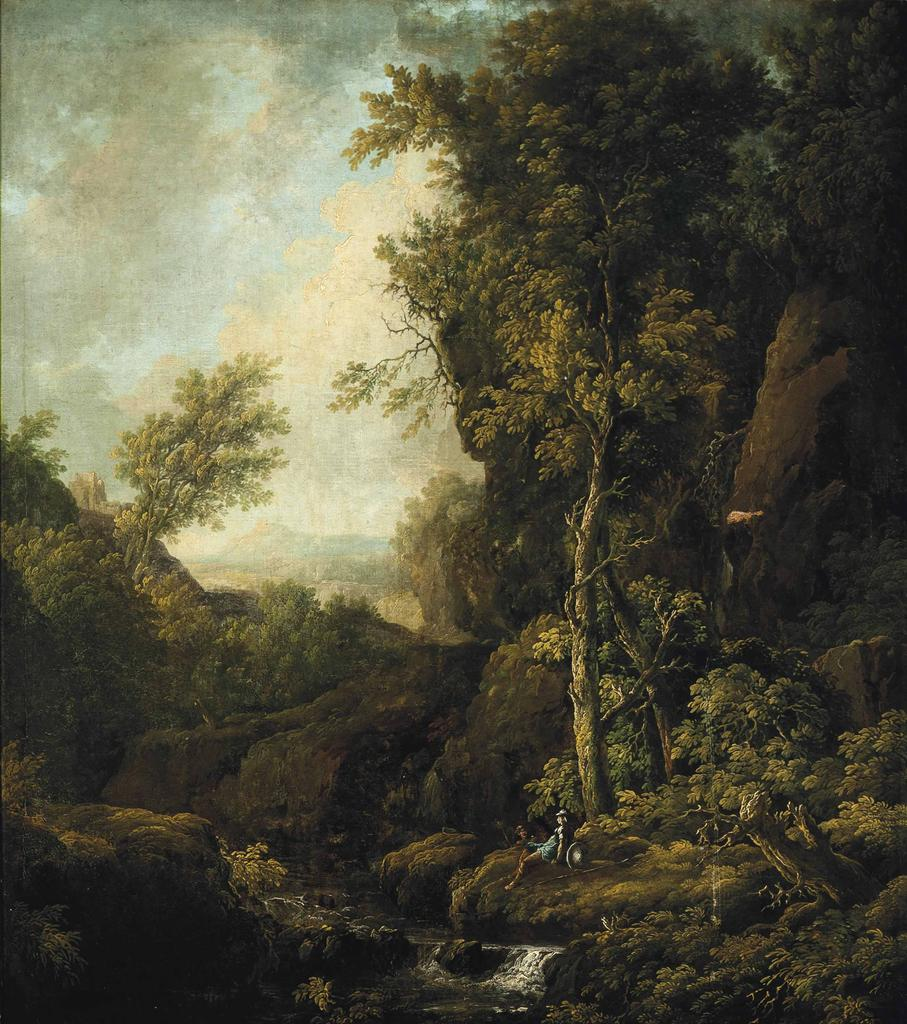What is the main subject of the image? There is a painting in the image. What elements are depicted in the painting? The painting contains trees and water. How many tigers can be seen swimming in the water in the painting? There are no tigers present in the painting; it contains trees and water. What type of cats are depicted in the painting? There are no cats depicted in the painting; it contains trees and water. 